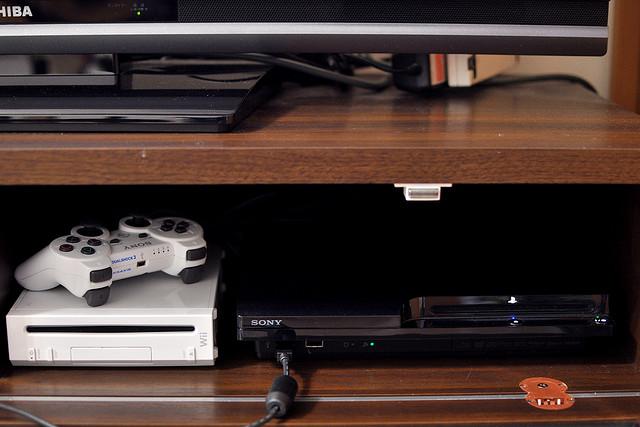What is the black video game console?
Quick response, please. Playstation. Is the tv on?
Give a very brief answer. Yes. How many items do you see?
Be succinct. 4. How many shelves are in the photo?
Give a very brief answer. 2. What are the items?
Keep it brief. Electronics. What color is the desk in which the TV stands?
Short answer required. Brown. What are they?
Concise answer only. Electronics. 